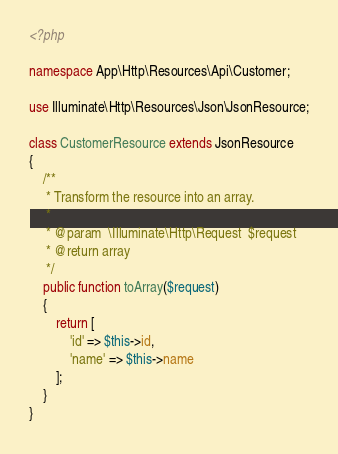Convert code to text. <code><loc_0><loc_0><loc_500><loc_500><_PHP_><?php

namespace App\Http\Resources\Api\Customer;

use Illuminate\Http\Resources\Json\JsonResource;

class CustomerResource extends JsonResource
{
    /**
     * Transform the resource into an array.
     *
     * @param  \Illuminate\Http\Request  $request
     * @return array
     */
    public function toArray($request)
    {
        return [
            'id' => $this->id,
            'name' => $this->name
        ];
    }
}
</code> 